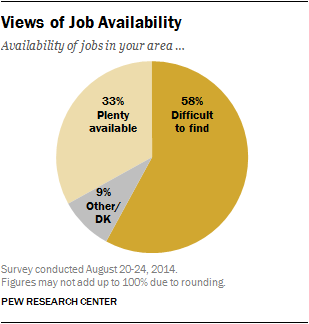List a handful of essential elements in this visual. The smallest section of the pie chart represents approximately 9% of the total. The largest and smallest pie sections have different measurements. 